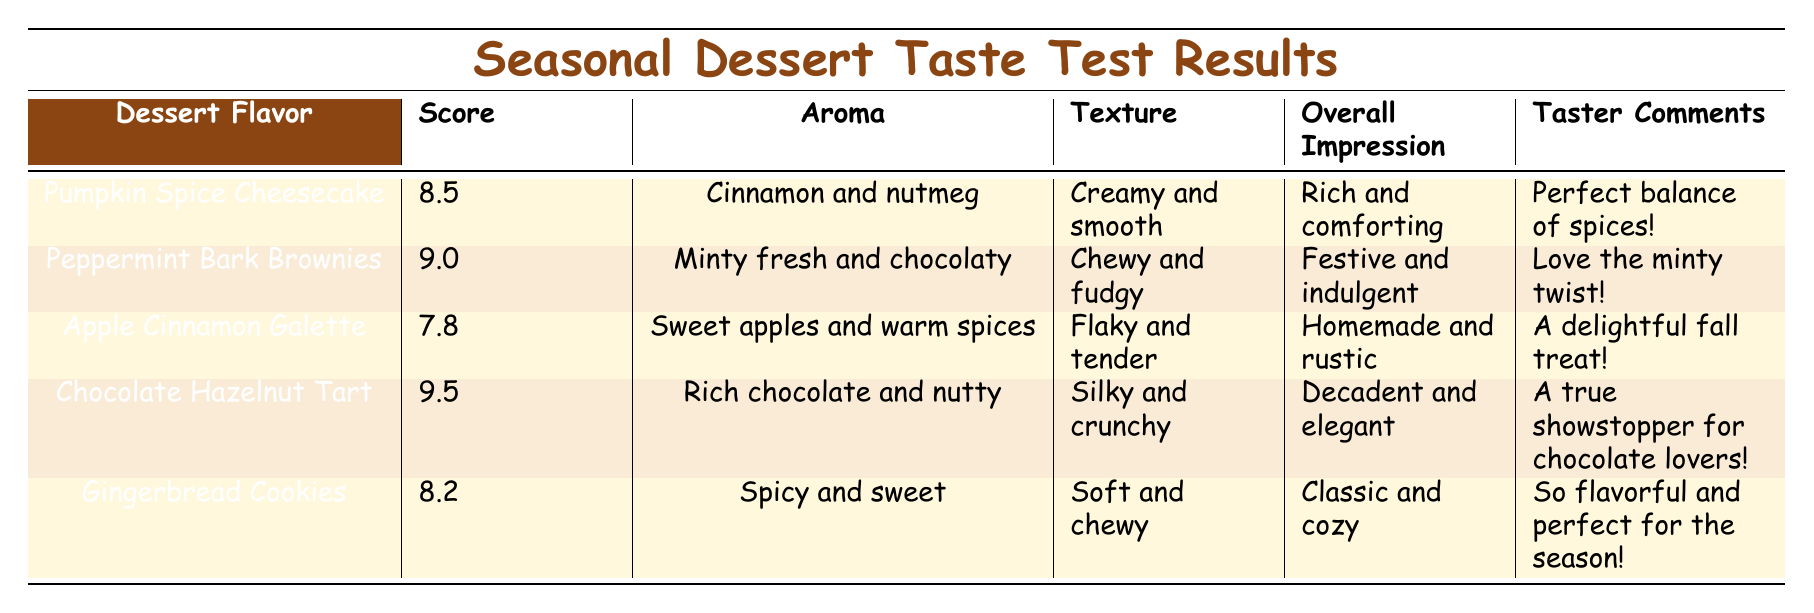What dessert flavor received the highest score? By looking at the scores for each dessert flavor, the Chocolate Hazelnut Tart has the highest score of 9.5.
Answer: Chocolate Hazelnut Tart What aroma accompanies the Peppermint Bark Brownies? The aroma listed for the Peppermint Bark Brownies is "Minty fresh and chocolaty."
Answer: Minty fresh and chocolaty What is the overall impression of the Apple Cinnamon Galette? According to the table, the overall impression given for the Apple Cinnamon Galette is "Homemade and rustic."
Answer: Homemade and rustic Is the score of Gingerbread Cookies higher than 8.0? The score of Gingerbread Cookies is 8.2, which is indeed higher than 8.0.
Answer: Yes What is the average score of the desserts listed? To calculate the average score, add all the scores together: (8.5 + 9.0 + 7.8 + 9.5 + 8.2) = 42.0. There are 5 desserts, so the average score is 42.0 / 5 = 8.4.
Answer: 8.4 Which dessert has the texture described as "Silky and crunchy"? The table indicates that the Chocolate Hazelnut Tart has a texture described as "Silky and crunchy."
Answer: Chocolate Hazelnut Tart Did the Pumpkin Spice Cheesecake receive a higher score than the Gingerbread Cookies? The Pumpkin Spice Cheesecake has a score of 8.5, while the Gingerbread Cookies have a score of 8.2. Since 8.5 is greater than 8.2, the statement is true.
Answer: Yes What dessert flavor has the comment "A true showstopper for chocolate lovers!"? This comment is attributed to the Chocolate Hazelnut Tart in the taster comments section.
Answer: Chocolate Hazelnut Tart How many desserts have a score of 9.0 or higher? The scores of the desserts are 8.5, 9.0, 7.8, 9.5, and 8.2. The desserts with scores of 9.0 or higher are Peppermint Bark Brownies (9.0) and Chocolate Hazelnut Tart (9.5), totaling 2 desserts.
Answer: 2 